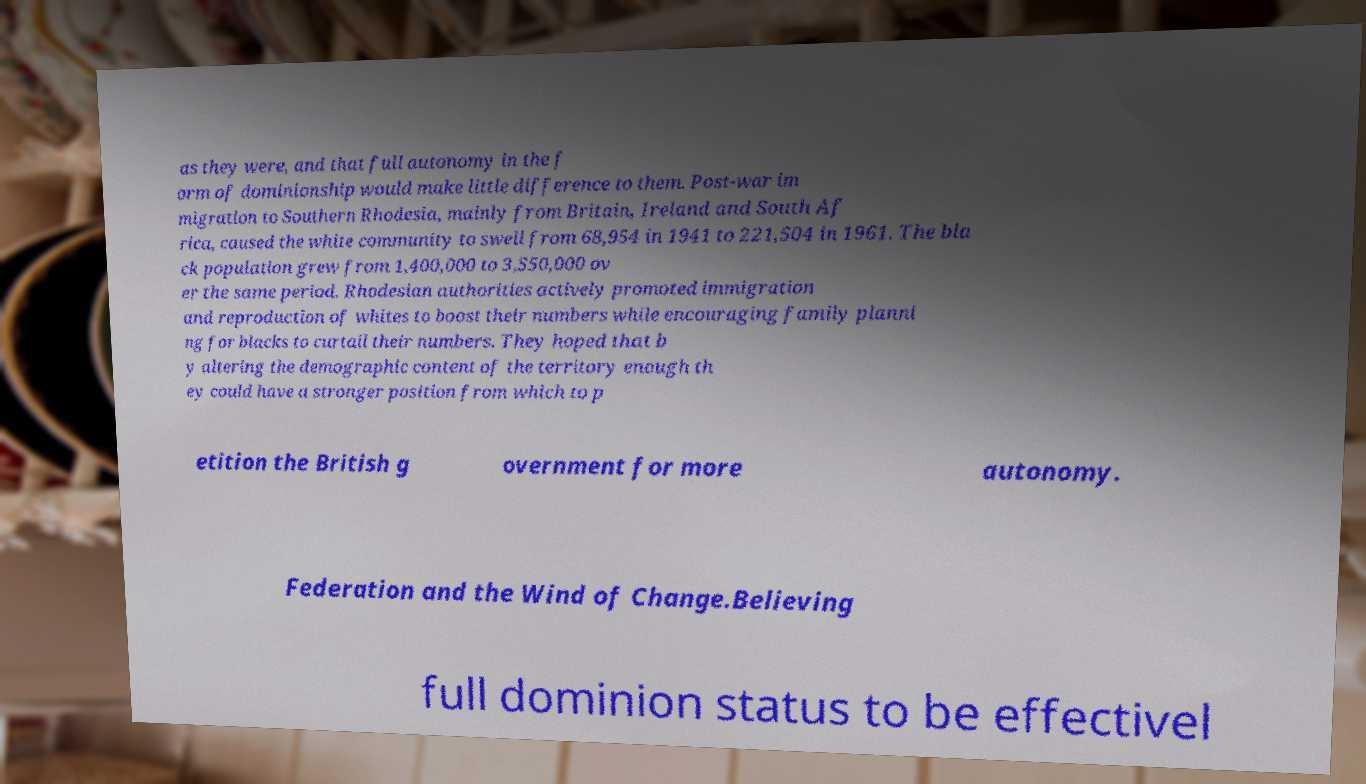Can you accurately transcribe the text from the provided image for me? as they were, and that full autonomy in the f orm of dominionship would make little difference to them. Post-war im migration to Southern Rhodesia, mainly from Britain, Ireland and South Af rica, caused the white community to swell from 68,954 in 1941 to 221,504 in 1961. The bla ck population grew from 1,400,000 to 3,550,000 ov er the same period. Rhodesian authorities actively promoted immigration and reproduction of whites to boost their numbers while encouraging family planni ng for blacks to curtail their numbers. They hoped that b y altering the demographic content of the territory enough th ey could have a stronger position from which to p etition the British g overnment for more autonomy. Federation and the Wind of Change.Believing full dominion status to be effectivel 